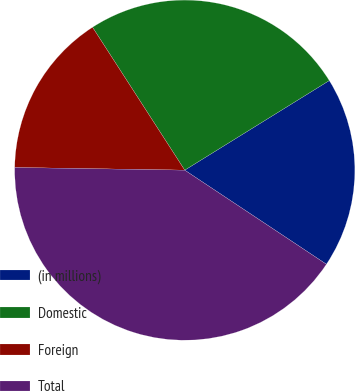Convert chart to OTSL. <chart><loc_0><loc_0><loc_500><loc_500><pie_chart><fcel>(in millions)<fcel>Domestic<fcel>Foreign<fcel>Total<nl><fcel>18.16%<fcel>25.29%<fcel>15.63%<fcel>40.92%<nl></chart> 